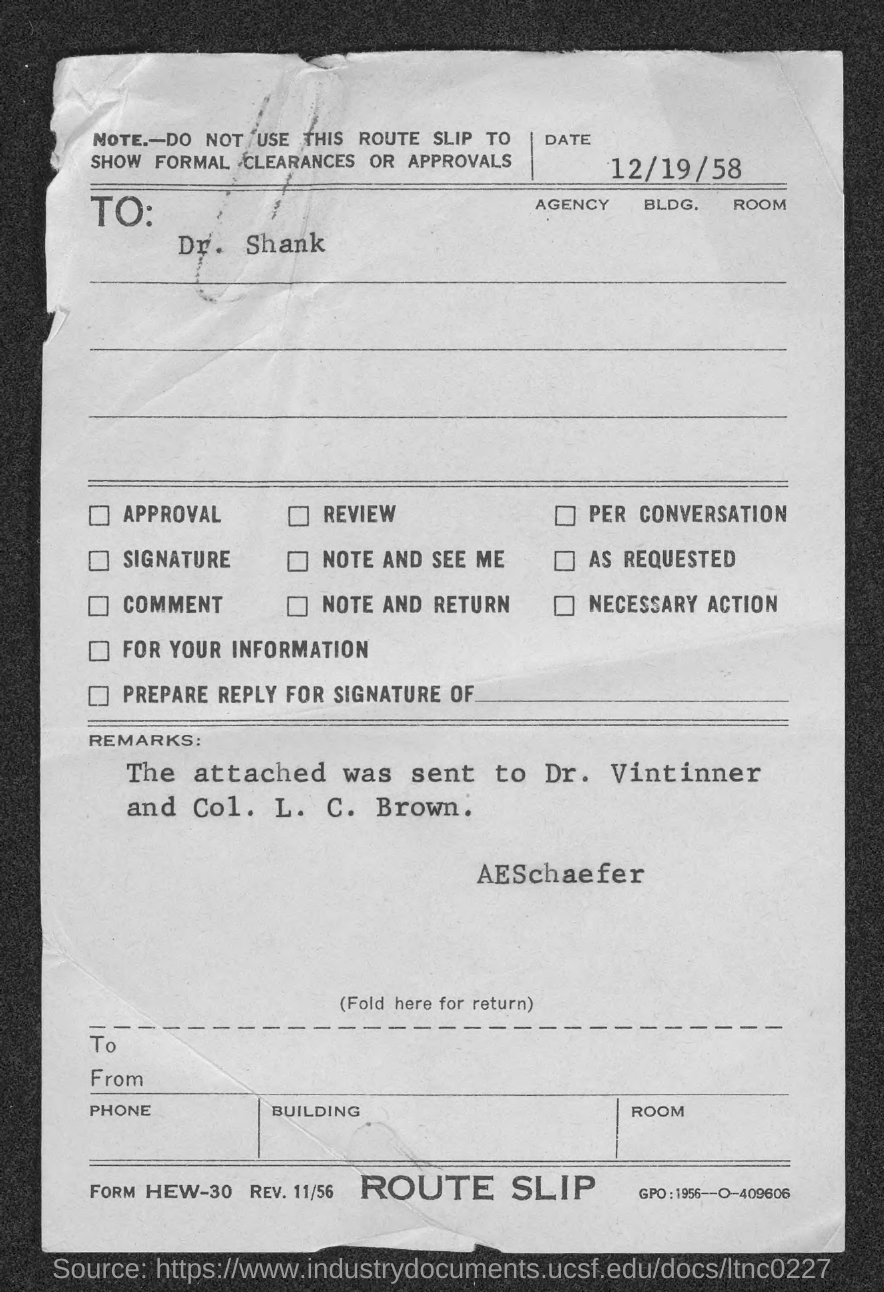What is the Date?
Make the answer very short. 12/19/58. To Whom is this letter addressed to?
Your response must be concise. Dr. Shank. 